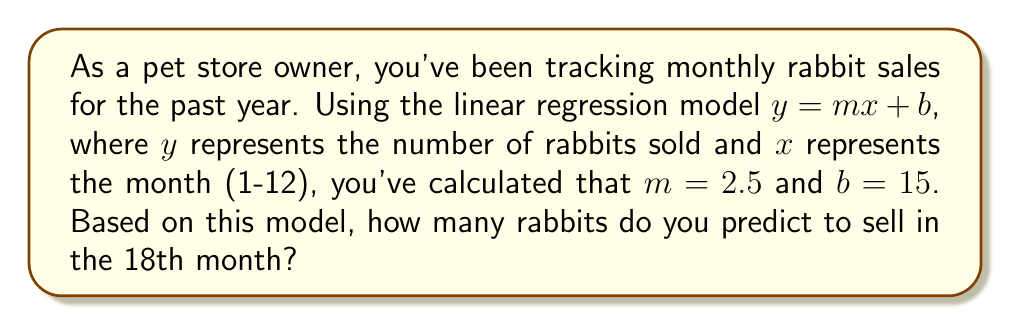Could you help me with this problem? Let's approach this step-by-step:

1) We're given the linear regression model: $y = mx + b$

2) We know the following:
   - $m = 2.5$ (slope)
   - $b = 15$ (y-intercept)
   - We want to predict for $x = 18$ (18th month)

3) Let's substitute these values into our equation:

   $y = 2.5x + 15$

4) Now, let's plug in $x = 18$:

   $y = 2.5(18) + 15$

5) Let's solve this:
   
   $y = 45 + 15$
   $y = 60$

Therefore, the model predicts that in the 18th month, 60 rabbits will be sold.
Answer: 60 rabbits 